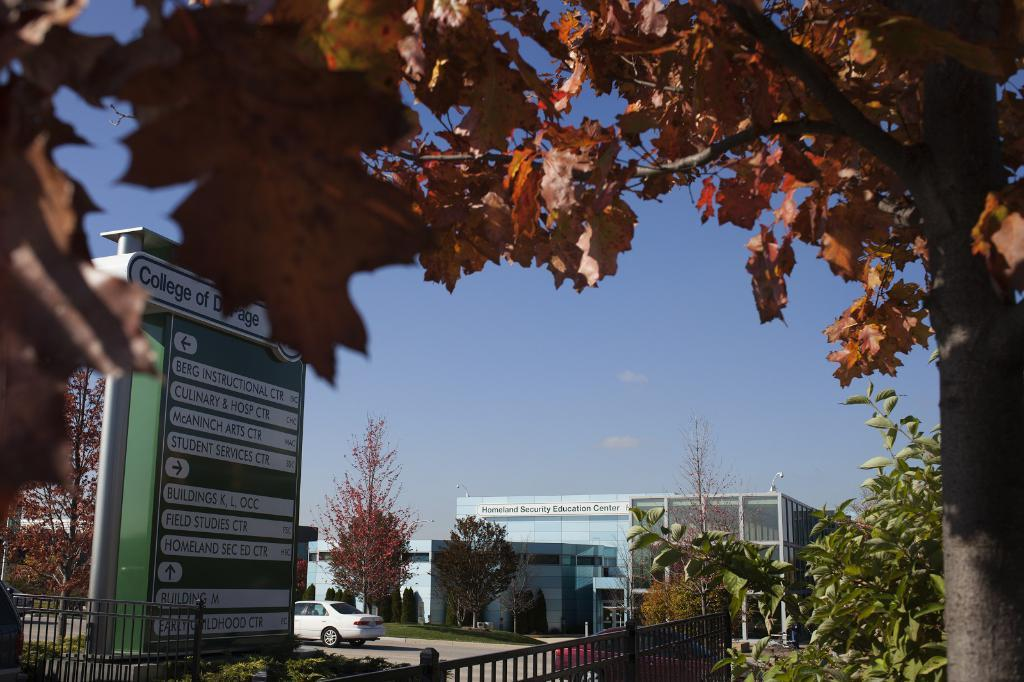What type of structure is visible in the image? There is a building in the image. What else can be seen on the ground in the image? There is a vehicle on the road in the image. What is the purpose of the barrier in the image? There is a fence in the image, which serves as a barrier or boundary. What is attached to the fence in the image? There is a board in the image, which is attached to the fence. What is written on the board in the image? There is text on the board in the image. What type of vegetation is present in the image? There are leaves and trees in the image. What is the color of the sky in the image? The sky is pale blue in the image. Can you tell me what type of kite the father is flying in the image? There is no father or kite present in the image. What type of legal advice is the lawyer providing in the image? There is no lawyer or legal advice present in the image. 